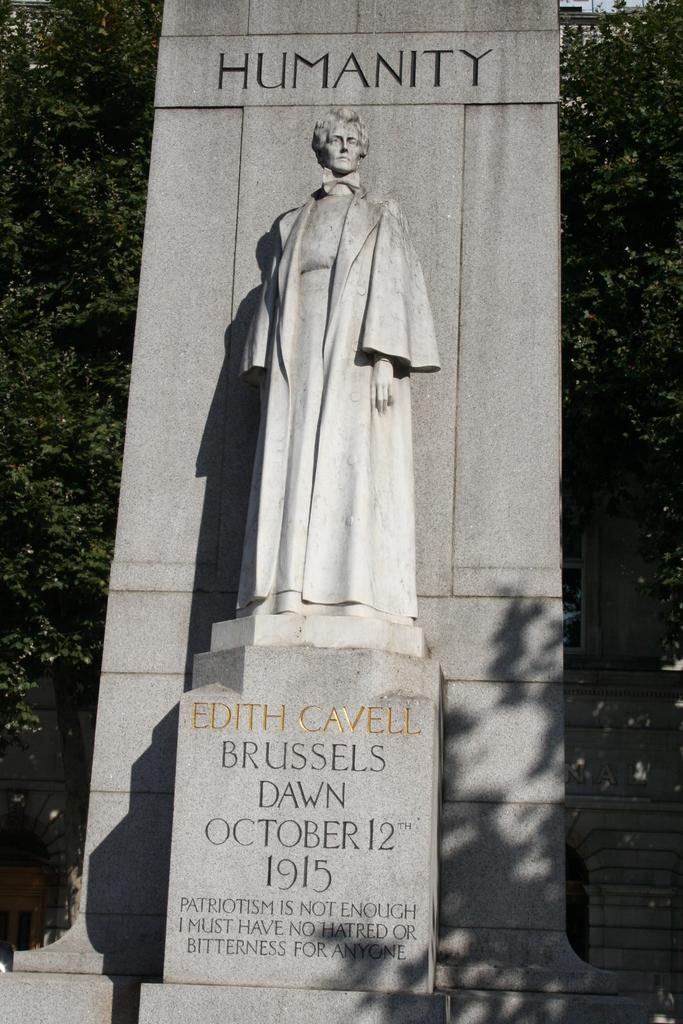What is the main subject in the center of the image? There is a statue in the center of the image. What can be seen in the background of the image? There are trees in the background of the image. What type of riddle is the statue solving in the image? There is no riddle present in the image; it only features a statue and trees in the background. 